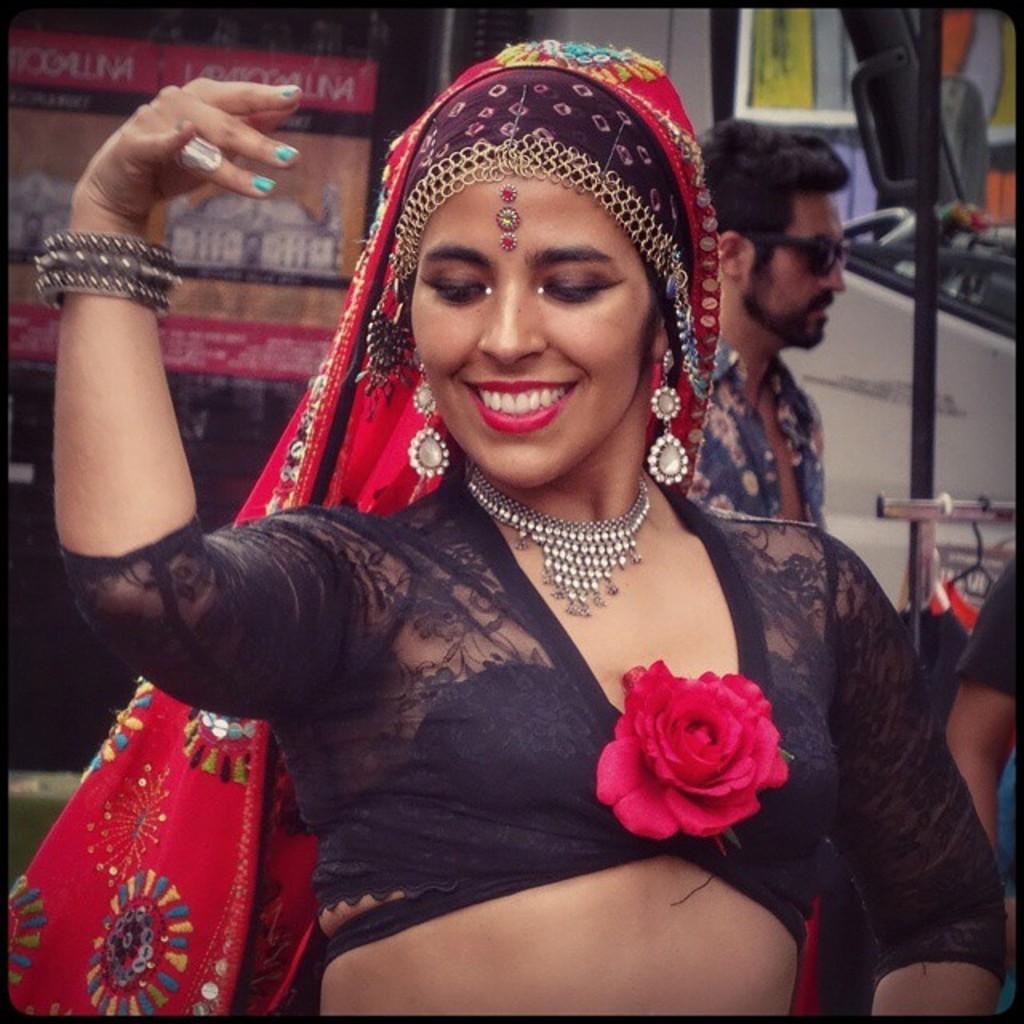Please provide a concise description of this image. In this image on the foreground there is a lady. She is dancing with a smiling face. In the background there are many , people, vehicles and hoardings. 